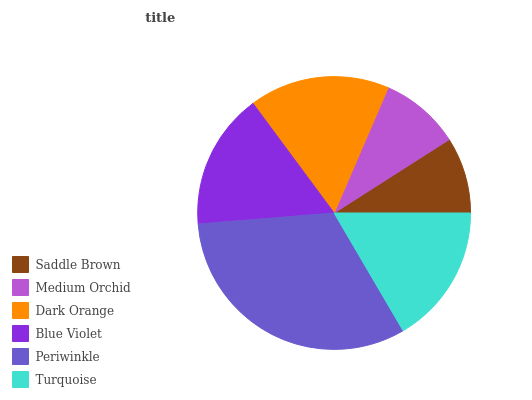Is Saddle Brown the minimum?
Answer yes or no. Yes. Is Periwinkle the maximum?
Answer yes or no. Yes. Is Medium Orchid the minimum?
Answer yes or no. No. Is Medium Orchid the maximum?
Answer yes or no. No. Is Medium Orchid greater than Saddle Brown?
Answer yes or no. Yes. Is Saddle Brown less than Medium Orchid?
Answer yes or no. Yes. Is Saddle Brown greater than Medium Orchid?
Answer yes or no. No. Is Medium Orchid less than Saddle Brown?
Answer yes or no. No. Is Turquoise the high median?
Answer yes or no. Yes. Is Blue Violet the low median?
Answer yes or no. Yes. Is Periwinkle the high median?
Answer yes or no. No. Is Turquoise the low median?
Answer yes or no. No. 